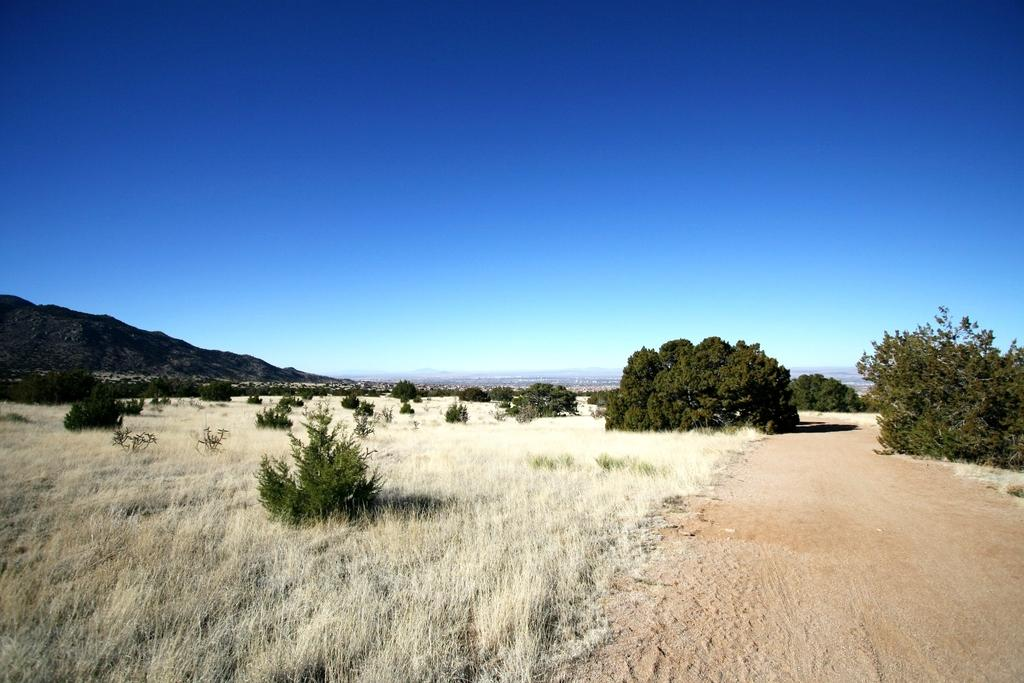What type of terrain is visible in the image? The ground is visible in the image, and there is grass present. Are there any plants visible in the image? Yes, there are green plants in the image. What can be seen in the background of the image? There are mountains and the sky visible in the background of the image. What is the profit margin of the grass in the image? There is no profit margin associated with the grass in the image, as it is a natural element and not a product or service. 